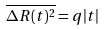<formula> <loc_0><loc_0><loc_500><loc_500>\overline { \Delta R ( t ) ^ { 2 } } = q | t |</formula> 